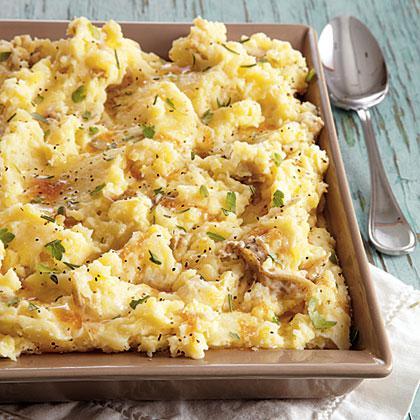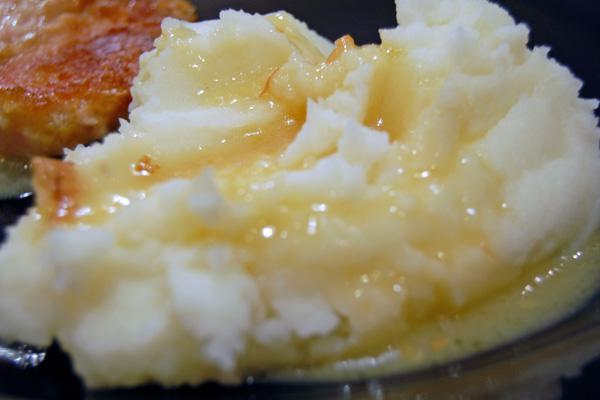The first image is the image on the left, the second image is the image on the right. Examine the images to the left and right. Is the description "the image on the left has potatoes in a square bowl" accurate? Answer yes or no. Yes. 